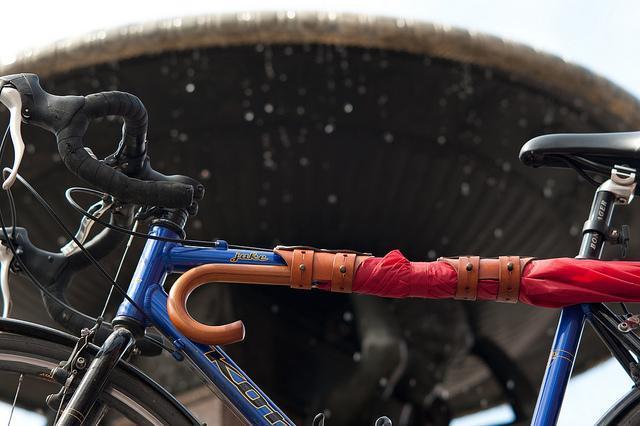How many people can ride this bike?
Give a very brief answer. 1. How many umbrellas are visible?
Give a very brief answer. 2. How many dogs are following the horse?
Give a very brief answer. 0. 